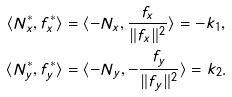Convert formula to latex. <formula><loc_0><loc_0><loc_500><loc_500>\langle N ^ { * } _ { x } , f ^ { * } _ { x } \rangle & = \langle - N _ { x } , \frac { f _ { x } } { \| f _ { x } \| ^ { 2 } } \rangle = - k _ { 1 } , \\ \langle N ^ { * } _ { y } , f ^ { * } _ { y } \rangle & = \langle - N _ { y } , - \frac { f _ { y } } { \| f _ { y } \| ^ { 2 } } \rangle = k _ { 2 } .</formula> 